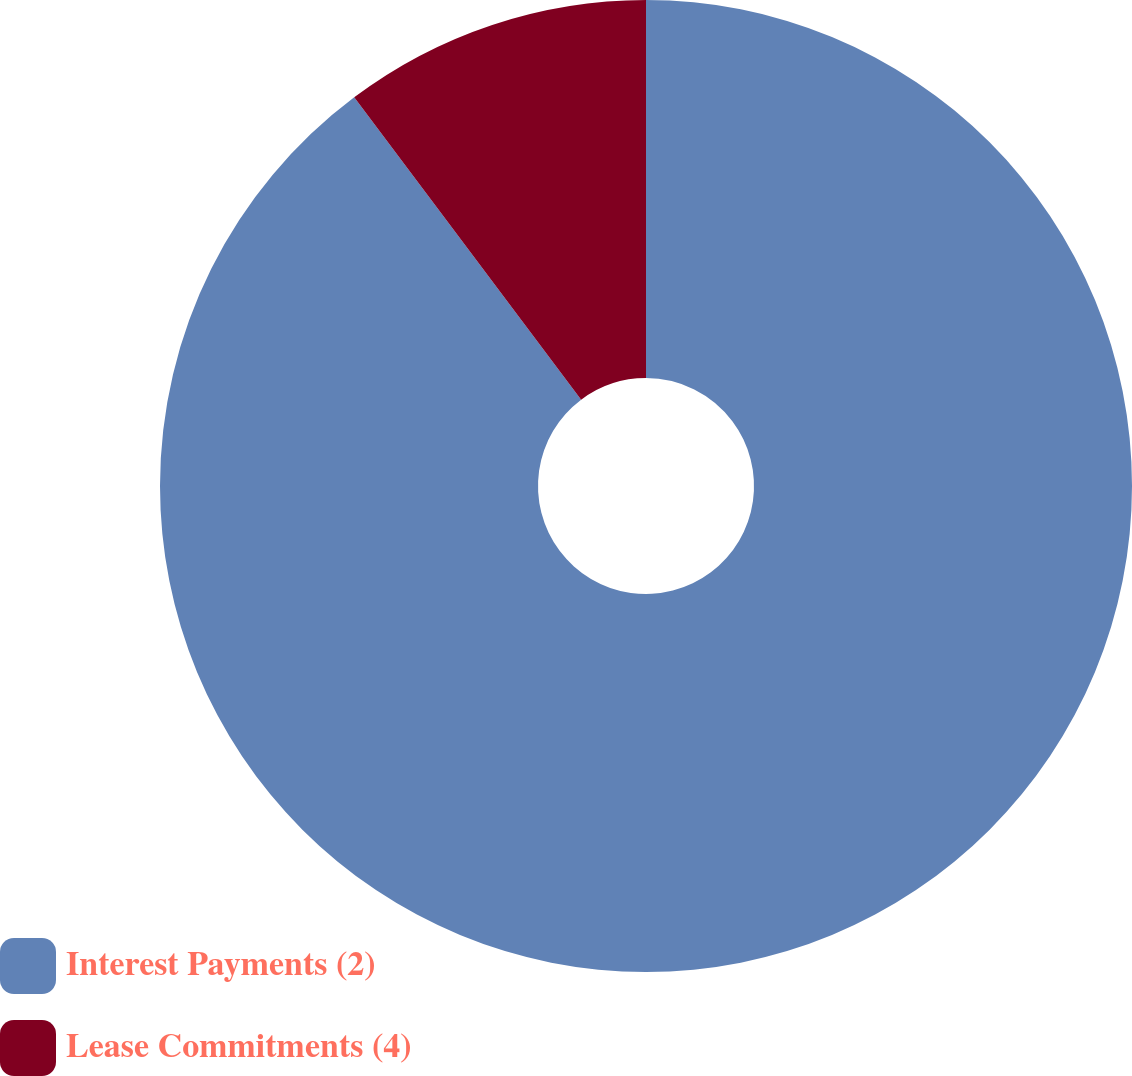Convert chart. <chart><loc_0><loc_0><loc_500><loc_500><pie_chart><fcel>Interest Payments (2)<fcel>Lease Commitments (4)<nl><fcel>89.75%<fcel>10.25%<nl></chart> 